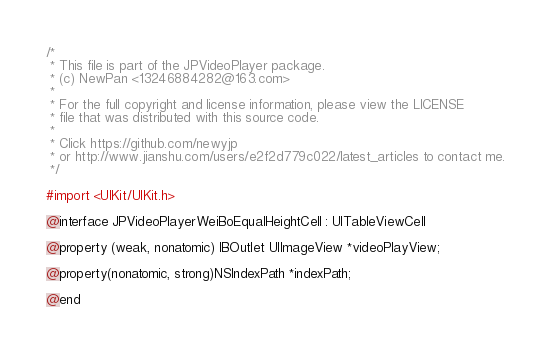Convert code to text. <code><loc_0><loc_0><loc_500><loc_500><_C_>/*
 * This file is part of the JPVideoPlayer package.
 * (c) NewPan <13246884282@163.com>
 *
 * For the full copyright and license information, please view the LICENSE
 * file that was distributed with this source code.
 *
 * Click https://github.com/newyjp
 * or http://www.jianshu.com/users/e2f2d779c022/latest_articles to contact me.
 */

#import <UIKit/UIKit.h>

@interface JPVideoPlayerWeiBoEqualHeightCell : UITableViewCell

@property (weak, nonatomic) IBOutlet UIImageView *videoPlayView;

@property(nonatomic, strong)NSIndexPath *indexPath;

@end
</code> 